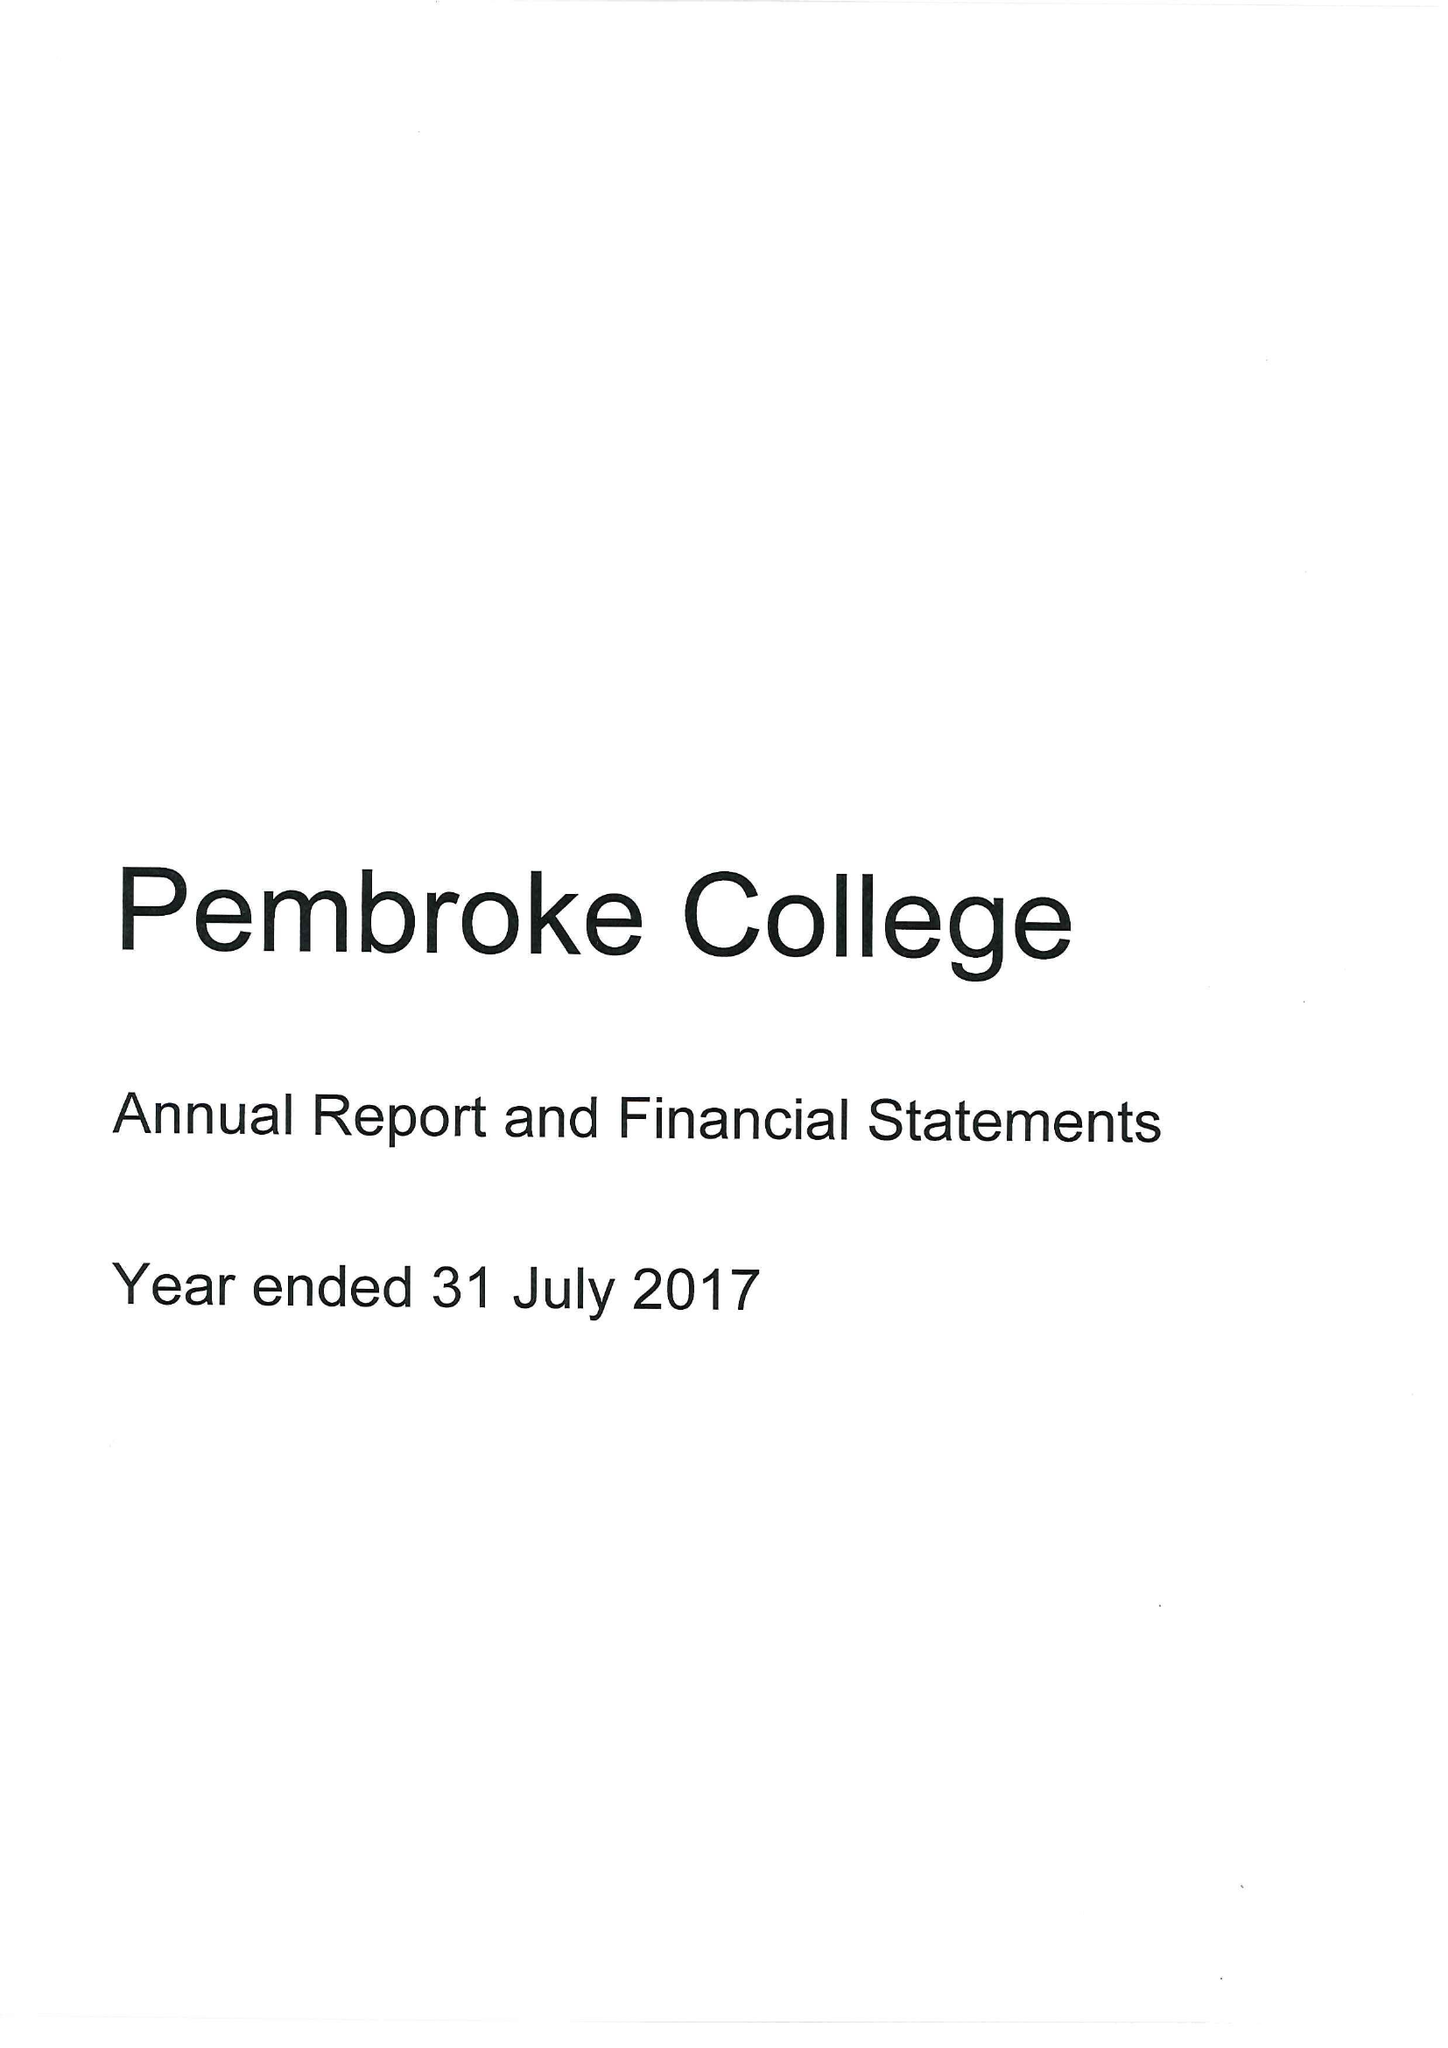What is the value for the address__postcode?
Answer the question using a single word or phrase. OX1 1DW 